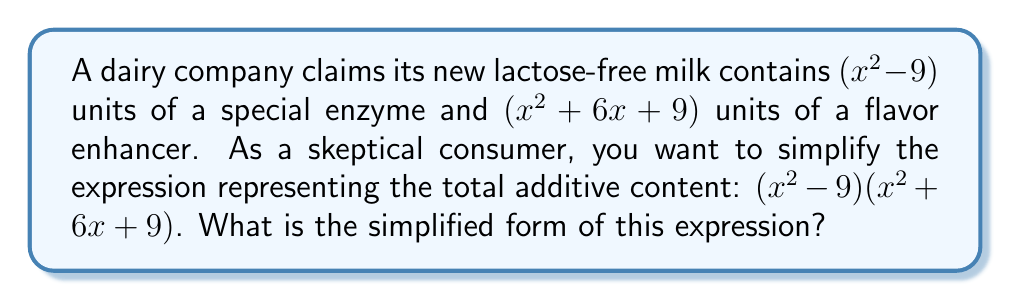Can you solve this math problem? Let's approach this step-by-step:

1) We're multiplying two binomials: $(x^2 - 9)(x^2 + 6x + 9)$

2) Recognize that $(x^2 - 9)$ is a difference of squares: $a^2 - b^2$ where $a = x$ and $b = 3$

3) The second factor $(x^2 + 6x + 9)$ is a perfect square trinomial: $(x + 3)^2$

4) Now we can rewrite our expression as:
   $$(x+3)(x-3)(x+3)^2$$

5) Simplify by combining like terms:
   $$(x+3)^2(x-3)$$

6) Expand this:
   $$(x+3)(x+3)(x-3)$$

7) Multiply the first two factors:
   $$(x^2 + 6x + 9)(x-3)$$

8) Now distribute:
   $$x^3 + 6x^2 + 9x - 3x^2 - 18x - 27$$

9) Combine like terms:
   $$x^3 + 3x^2 - 9x - 27$$

This final form represents the simplified expression for the total additive content, revealing the actual polynomial relationship between the ingredients (represented by $x$) and the consumer's skepticism about the product claims.
Answer: $x^3 + 3x^2 - 9x - 27$ 